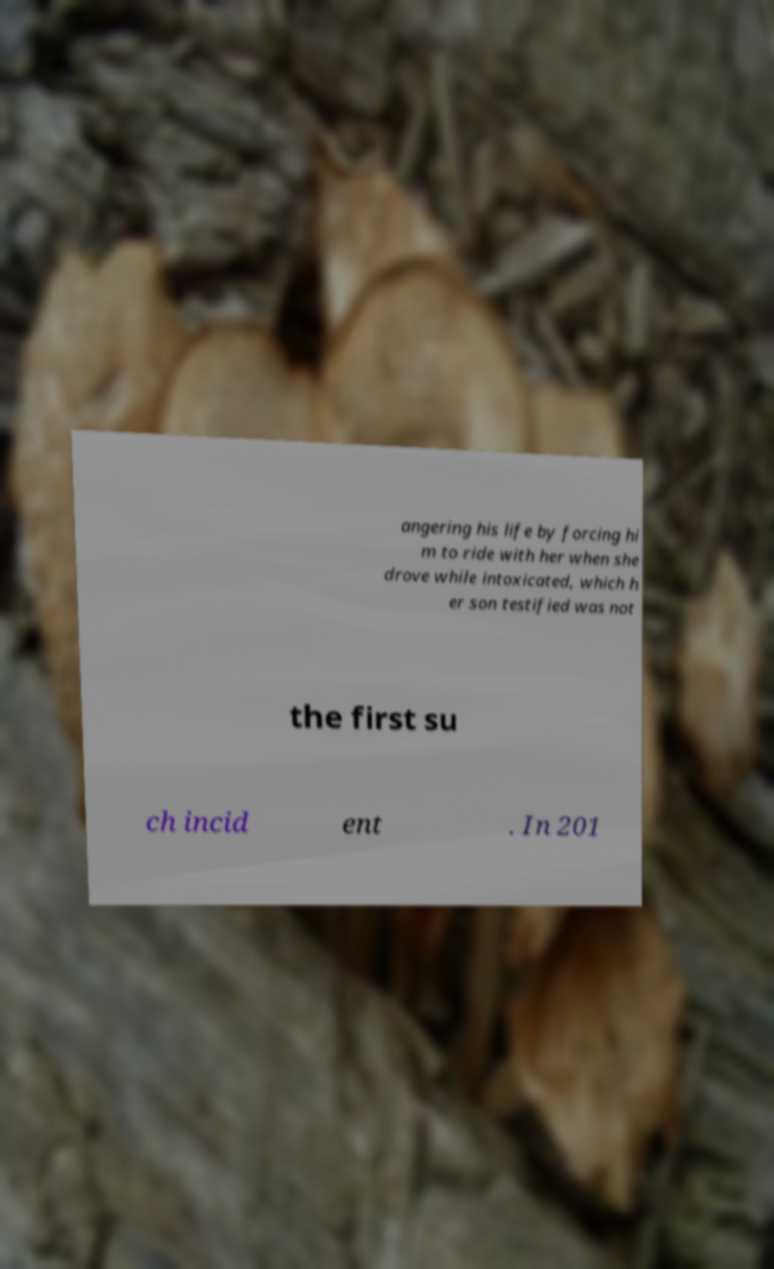Could you extract and type out the text from this image? angering his life by forcing hi m to ride with her when she drove while intoxicated, which h er son testified was not the first su ch incid ent . In 201 